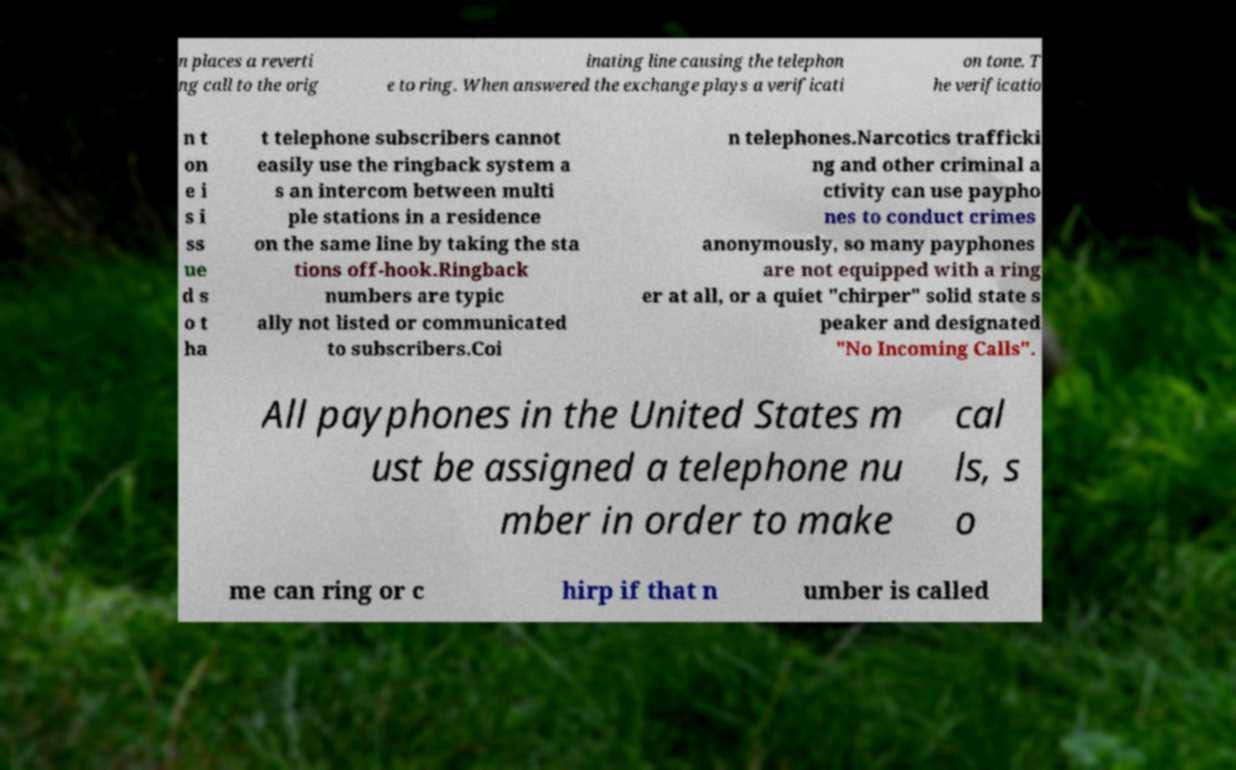Can you read and provide the text displayed in the image?This photo seems to have some interesting text. Can you extract and type it out for me? n places a reverti ng call to the orig inating line causing the telephon e to ring. When answered the exchange plays a verificati on tone. T he verificatio n t on e i s i ss ue d s o t ha t telephone subscribers cannot easily use the ringback system a s an intercom between multi ple stations in a residence on the same line by taking the sta tions off-hook.Ringback numbers are typic ally not listed or communicated to subscribers.Coi n telephones.Narcotics trafficki ng and other criminal a ctivity can use paypho nes to conduct crimes anonymously, so many payphones are not equipped with a ring er at all, or a quiet "chirper" solid state s peaker and designated "No Incoming Calls". All payphones in the United States m ust be assigned a telephone nu mber in order to make cal ls, s o me can ring or c hirp if that n umber is called 